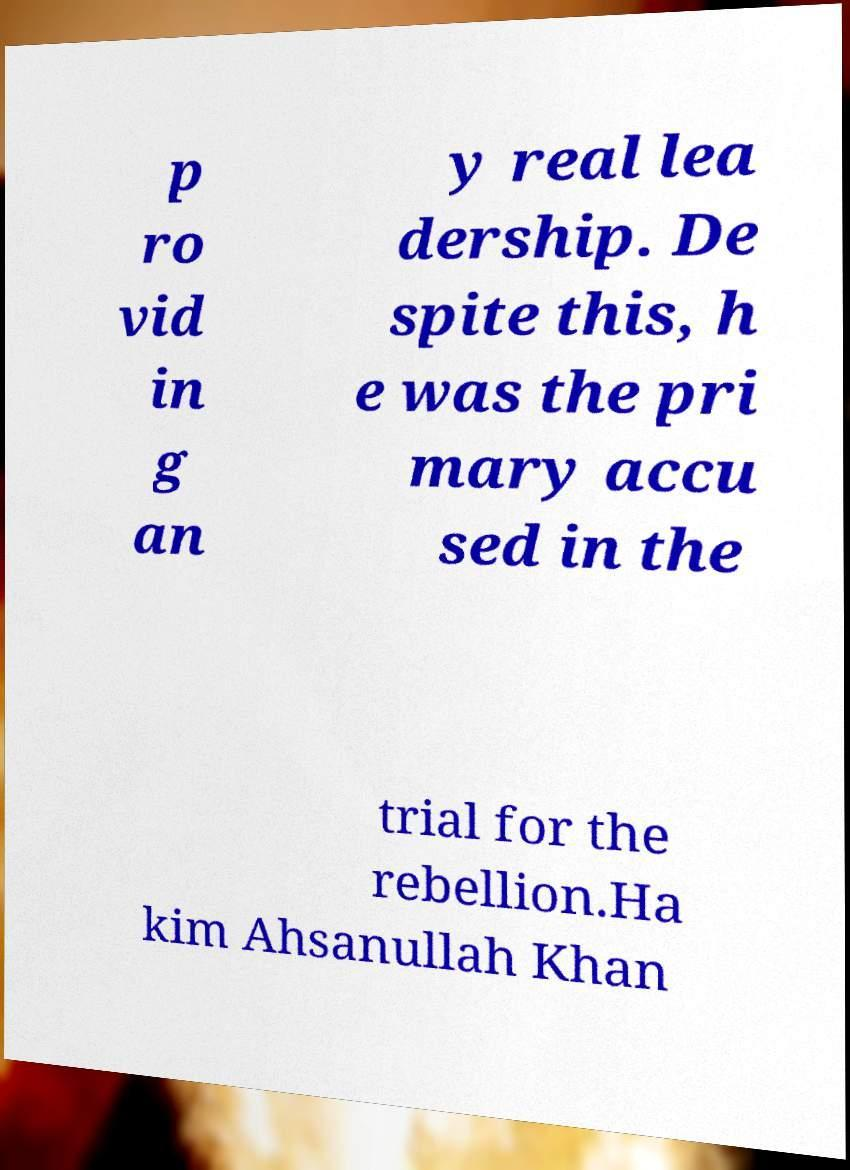Can you read and provide the text displayed in the image?This photo seems to have some interesting text. Can you extract and type it out for me? p ro vid in g an y real lea dership. De spite this, h e was the pri mary accu sed in the trial for the rebellion.Ha kim Ahsanullah Khan 